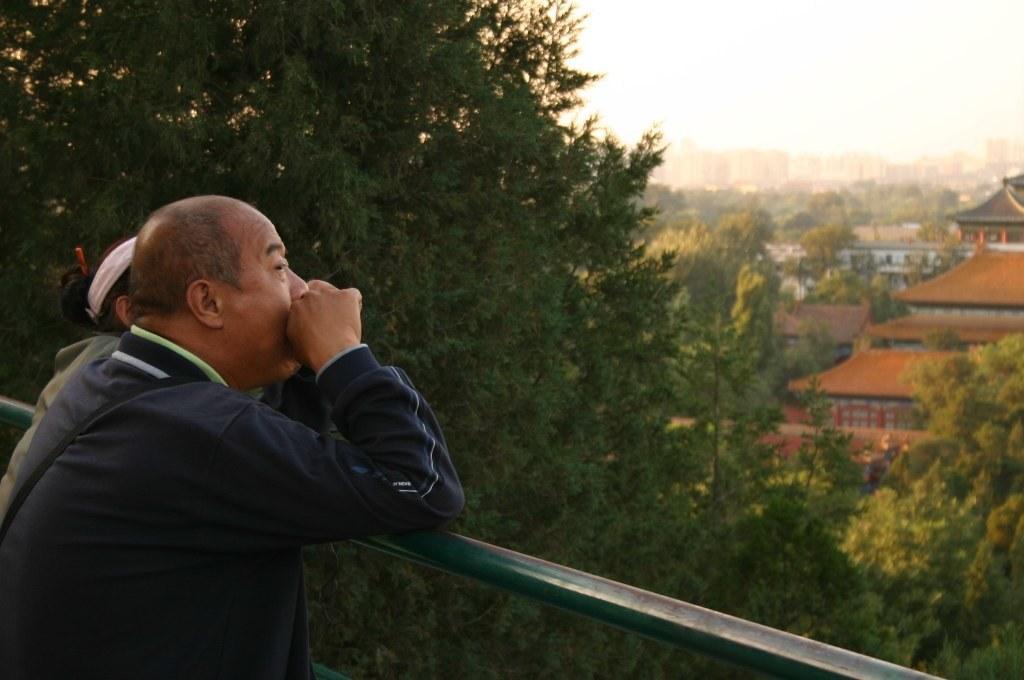In one or two sentences, can you explain what this image depicts? In the foreground of this image, there is a man and a woman standing near railing. In the background, trees, buildings and the sky. 